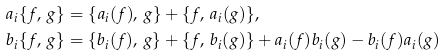<formula> <loc_0><loc_0><loc_500><loc_500>a _ { i } \{ f , \, g \} & = \{ a _ { i } ( f ) , \, g \} + \{ f , \, a _ { i } ( g ) \} , \\ b _ { i } \{ f , \, g \} & = \{ b _ { i } ( f ) , \, g \} + \{ f , \, b _ { i } ( g ) \} + a _ { i } ( f ) b _ { i } ( g ) - b _ { i } ( f ) a _ { i } ( g )</formula> 